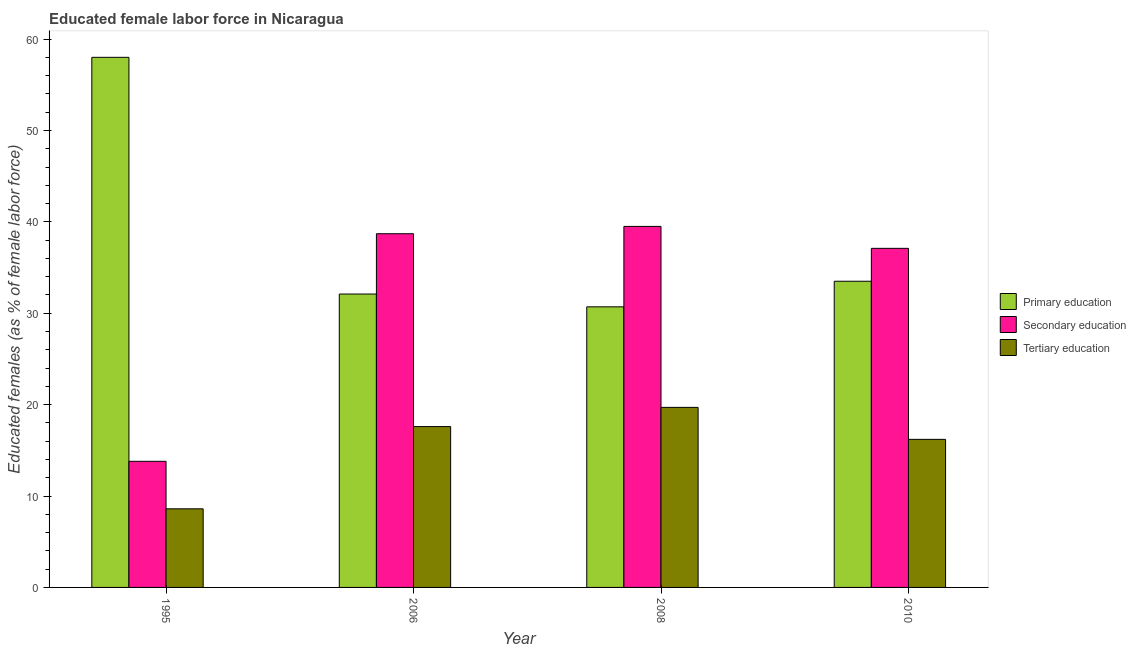How many groups of bars are there?
Give a very brief answer. 4. Are the number of bars per tick equal to the number of legend labels?
Ensure brevity in your answer.  Yes. Are the number of bars on each tick of the X-axis equal?
Your response must be concise. Yes. What is the label of the 3rd group of bars from the left?
Keep it short and to the point. 2008. What is the percentage of female labor force who received secondary education in 1995?
Provide a succinct answer. 13.8. Across all years, what is the maximum percentage of female labor force who received primary education?
Offer a terse response. 58. Across all years, what is the minimum percentage of female labor force who received tertiary education?
Offer a terse response. 8.6. In which year was the percentage of female labor force who received tertiary education maximum?
Provide a short and direct response. 2008. What is the total percentage of female labor force who received tertiary education in the graph?
Make the answer very short. 62.1. What is the difference between the percentage of female labor force who received secondary education in 1995 and that in 2006?
Offer a very short reply. -24.9. What is the difference between the percentage of female labor force who received tertiary education in 2010 and the percentage of female labor force who received secondary education in 1995?
Ensure brevity in your answer.  7.6. What is the average percentage of female labor force who received secondary education per year?
Offer a very short reply. 32.27. In how many years, is the percentage of female labor force who received tertiary education greater than 40 %?
Offer a very short reply. 0. What is the ratio of the percentage of female labor force who received tertiary education in 1995 to that in 2006?
Offer a very short reply. 0.49. What is the difference between the highest and the second highest percentage of female labor force who received primary education?
Keep it short and to the point. 24.5. What is the difference between the highest and the lowest percentage of female labor force who received tertiary education?
Offer a very short reply. 11.1. In how many years, is the percentage of female labor force who received tertiary education greater than the average percentage of female labor force who received tertiary education taken over all years?
Your answer should be very brief. 3. What does the 2nd bar from the left in 1995 represents?
Give a very brief answer. Secondary education. What does the 3rd bar from the right in 2006 represents?
Your answer should be compact. Primary education. Is it the case that in every year, the sum of the percentage of female labor force who received primary education and percentage of female labor force who received secondary education is greater than the percentage of female labor force who received tertiary education?
Ensure brevity in your answer.  Yes. Are all the bars in the graph horizontal?
Give a very brief answer. No. How many years are there in the graph?
Provide a short and direct response. 4. What is the difference between two consecutive major ticks on the Y-axis?
Offer a very short reply. 10. Does the graph contain any zero values?
Make the answer very short. No. Does the graph contain grids?
Ensure brevity in your answer.  No. How are the legend labels stacked?
Give a very brief answer. Vertical. What is the title of the graph?
Make the answer very short. Educated female labor force in Nicaragua. Does "Errors" appear as one of the legend labels in the graph?
Keep it short and to the point. No. What is the label or title of the Y-axis?
Your answer should be compact. Educated females (as % of female labor force). What is the Educated females (as % of female labor force) in Primary education in 1995?
Offer a terse response. 58. What is the Educated females (as % of female labor force) of Secondary education in 1995?
Your answer should be very brief. 13.8. What is the Educated females (as % of female labor force) of Tertiary education in 1995?
Keep it short and to the point. 8.6. What is the Educated females (as % of female labor force) in Primary education in 2006?
Offer a terse response. 32.1. What is the Educated females (as % of female labor force) of Secondary education in 2006?
Give a very brief answer. 38.7. What is the Educated females (as % of female labor force) of Tertiary education in 2006?
Offer a very short reply. 17.6. What is the Educated females (as % of female labor force) of Primary education in 2008?
Your response must be concise. 30.7. What is the Educated females (as % of female labor force) of Secondary education in 2008?
Ensure brevity in your answer.  39.5. What is the Educated females (as % of female labor force) of Tertiary education in 2008?
Keep it short and to the point. 19.7. What is the Educated females (as % of female labor force) of Primary education in 2010?
Give a very brief answer. 33.5. What is the Educated females (as % of female labor force) in Secondary education in 2010?
Your answer should be very brief. 37.1. What is the Educated females (as % of female labor force) of Tertiary education in 2010?
Give a very brief answer. 16.2. Across all years, what is the maximum Educated females (as % of female labor force) of Primary education?
Give a very brief answer. 58. Across all years, what is the maximum Educated females (as % of female labor force) of Secondary education?
Offer a terse response. 39.5. Across all years, what is the maximum Educated females (as % of female labor force) in Tertiary education?
Your answer should be compact. 19.7. Across all years, what is the minimum Educated females (as % of female labor force) of Primary education?
Provide a succinct answer. 30.7. Across all years, what is the minimum Educated females (as % of female labor force) in Secondary education?
Offer a very short reply. 13.8. Across all years, what is the minimum Educated females (as % of female labor force) in Tertiary education?
Keep it short and to the point. 8.6. What is the total Educated females (as % of female labor force) of Primary education in the graph?
Your response must be concise. 154.3. What is the total Educated females (as % of female labor force) of Secondary education in the graph?
Your response must be concise. 129.1. What is the total Educated females (as % of female labor force) in Tertiary education in the graph?
Ensure brevity in your answer.  62.1. What is the difference between the Educated females (as % of female labor force) in Primary education in 1995 and that in 2006?
Keep it short and to the point. 25.9. What is the difference between the Educated females (as % of female labor force) of Secondary education in 1995 and that in 2006?
Provide a short and direct response. -24.9. What is the difference between the Educated females (as % of female labor force) in Primary education in 1995 and that in 2008?
Your answer should be very brief. 27.3. What is the difference between the Educated females (as % of female labor force) in Secondary education in 1995 and that in 2008?
Your response must be concise. -25.7. What is the difference between the Educated females (as % of female labor force) in Secondary education in 1995 and that in 2010?
Your response must be concise. -23.3. What is the difference between the Educated females (as % of female labor force) in Primary education in 2006 and that in 2008?
Provide a short and direct response. 1.4. What is the difference between the Educated females (as % of female labor force) in Secondary education in 2006 and that in 2008?
Keep it short and to the point. -0.8. What is the difference between the Educated females (as % of female labor force) in Tertiary education in 2006 and that in 2008?
Provide a short and direct response. -2.1. What is the difference between the Educated females (as % of female labor force) of Primary education in 2006 and that in 2010?
Offer a terse response. -1.4. What is the difference between the Educated females (as % of female labor force) of Secondary education in 2006 and that in 2010?
Provide a succinct answer. 1.6. What is the difference between the Educated females (as % of female labor force) of Tertiary education in 2006 and that in 2010?
Give a very brief answer. 1.4. What is the difference between the Educated females (as % of female labor force) in Secondary education in 2008 and that in 2010?
Your answer should be very brief. 2.4. What is the difference between the Educated females (as % of female labor force) of Primary education in 1995 and the Educated females (as % of female labor force) of Secondary education in 2006?
Offer a very short reply. 19.3. What is the difference between the Educated females (as % of female labor force) of Primary education in 1995 and the Educated females (as % of female labor force) of Tertiary education in 2006?
Give a very brief answer. 40.4. What is the difference between the Educated females (as % of female labor force) in Primary education in 1995 and the Educated females (as % of female labor force) in Secondary education in 2008?
Your response must be concise. 18.5. What is the difference between the Educated females (as % of female labor force) in Primary education in 1995 and the Educated females (as % of female labor force) in Tertiary education in 2008?
Your response must be concise. 38.3. What is the difference between the Educated females (as % of female labor force) in Secondary education in 1995 and the Educated females (as % of female labor force) in Tertiary education in 2008?
Your answer should be compact. -5.9. What is the difference between the Educated females (as % of female labor force) in Primary education in 1995 and the Educated females (as % of female labor force) in Secondary education in 2010?
Your response must be concise. 20.9. What is the difference between the Educated females (as % of female labor force) in Primary education in 1995 and the Educated females (as % of female labor force) in Tertiary education in 2010?
Your response must be concise. 41.8. What is the difference between the Educated females (as % of female labor force) in Secondary education in 1995 and the Educated females (as % of female labor force) in Tertiary education in 2010?
Your answer should be compact. -2.4. What is the difference between the Educated females (as % of female labor force) of Primary education in 2006 and the Educated females (as % of female labor force) of Tertiary education in 2008?
Your answer should be very brief. 12.4. What is the difference between the Educated females (as % of female labor force) in Primary education in 2006 and the Educated females (as % of female labor force) in Tertiary education in 2010?
Provide a short and direct response. 15.9. What is the difference between the Educated females (as % of female labor force) in Secondary education in 2006 and the Educated females (as % of female labor force) in Tertiary education in 2010?
Keep it short and to the point. 22.5. What is the difference between the Educated females (as % of female labor force) in Secondary education in 2008 and the Educated females (as % of female labor force) in Tertiary education in 2010?
Your answer should be very brief. 23.3. What is the average Educated females (as % of female labor force) of Primary education per year?
Give a very brief answer. 38.58. What is the average Educated females (as % of female labor force) in Secondary education per year?
Make the answer very short. 32.27. What is the average Educated females (as % of female labor force) of Tertiary education per year?
Ensure brevity in your answer.  15.53. In the year 1995, what is the difference between the Educated females (as % of female labor force) in Primary education and Educated females (as % of female labor force) in Secondary education?
Offer a very short reply. 44.2. In the year 1995, what is the difference between the Educated females (as % of female labor force) of Primary education and Educated females (as % of female labor force) of Tertiary education?
Make the answer very short. 49.4. In the year 2006, what is the difference between the Educated females (as % of female labor force) in Primary education and Educated females (as % of female labor force) in Tertiary education?
Offer a terse response. 14.5. In the year 2006, what is the difference between the Educated females (as % of female labor force) in Secondary education and Educated females (as % of female labor force) in Tertiary education?
Offer a very short reply. 21.1. In the year 2008, what is the difference between the Educated females (as % of female labor force) in Secondary education and Educated females (as % of female labor force) in Tertiary education?
Offer a very short reply. 19.8. In the year 2010, what is the difference between the Educated females (as % of female labor force) in Primary education and Educated females (as % of female labor force) in Tertiary education?
Your answer should be very brief. 17.3. In the year 2010, what is the difference between the Educated females (as % of female labor force) in Secondary education and Educated females (as % of female labor force) in Tertiary education?
Provide a short and direct response. 20.9. What is the ratio of the Educated females (as % of female labor force) of Primary education in 1995 to that in 2006?
Offer a terse response. 1.81. What is the ratio of the Educated females (as % of female labor force) in Secondary education in 1995 to that in 2006?
Make the answer very short. 0.36. What is the ratio of the Educated females (as % of female labor force) in Tertiary education in 1995 to that in 2006?
Provide a short and direct response. 0.49. What is the ratio of the Educated females (as % of female labor force) in Primary education in 1995 to that in 2008?
Your answer should be very brief. 1.89. What is the ratio of the Educated females (as % of female labor force) of Secondary education in 1995 to that in 2008?
Ensure brevity in your answer.  0.35. What is the ratio of the Educated females (as % of female labor force) of Tertiary education in 1995 to that in 2008?
Keep it short and to the point. 0.44. What is the ratio of the Educated females (as % of female labor force) of Primary education in 1995 to that in 2010?
Your response must be concise. 1.73. What is the ratio of the Educated females (as % of female labor force) of Secondary education in 1995 to that in 2010?
Provide a succinct answer. 0.37. What is the ratio of the Educated females (as % of female labor force) of Tertiary education in 1995 to that in 2010?
Provide a short and direct response. 0.53. What is the ratio of the Educated females (as % of female labor force) of Primary education in 2006 to that in 2008?
Give a very brief answer. 1.05. What is the ratio of the Educated females (as % of female labor force) of Secondary education in 2006 to that in 2008?
Offer a terse response. 0.98. What is the ratio of the Educated females (as % of female labor force) of Tertiary education in 2006 to that in 2008?
Your response must be concise. 0.89. What is the ratio of the Educated females (as % of female labor force) in Primary education in 2006 to that in 2010?
Your answer should be compact. 0.96. What is the ratio of the Educated females (as % of female labor force) of Secondary education in 2006 to that in 2010?
Offer a very short reply. 1.04. What is the ratio of the Educated females (as % of female labor force) in Tertiary education in 2006 to that in 2010?
Provide a succinct answer. 1.09. What is the ratio of the Educated females (as % of female labor force) in Primary education in 2008 to that in 2010?
Make the answer very short. 0.92. What is the ratio of the Educated females (as % of female labor force) of Secondary education in 2008 to that in 2010?
Your response must be concise. 1.06. What is the ratio of the Educated females (as % of female labor force) in Tertiary education in 2008 to that in 2010?
Keep it short and to the point. 1.22. What is the difference between the highest and the lowest Educated females (as % of female labor force) of Primary education?
Make the answer very short. 27.3. What is the difference between the highest and the lowest Educated females (as % of female labor force) of Secondary education?
Your answer should be compact. 25.7. What is the difference between the highest and the lowest Educated females (as % of female labor force) of Tertiary education?
Your answer should be compact. 11.1. 